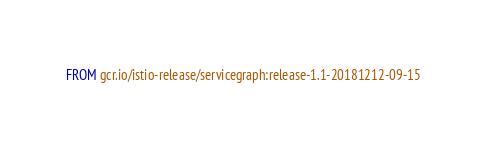Convert code to text. <code><loc_0><loc_0><loc_500><loc_500><_Dockerfile_>FROM gcr.io/istio-release/servicegraph:release-1.1-20181212-09-15
</code> 